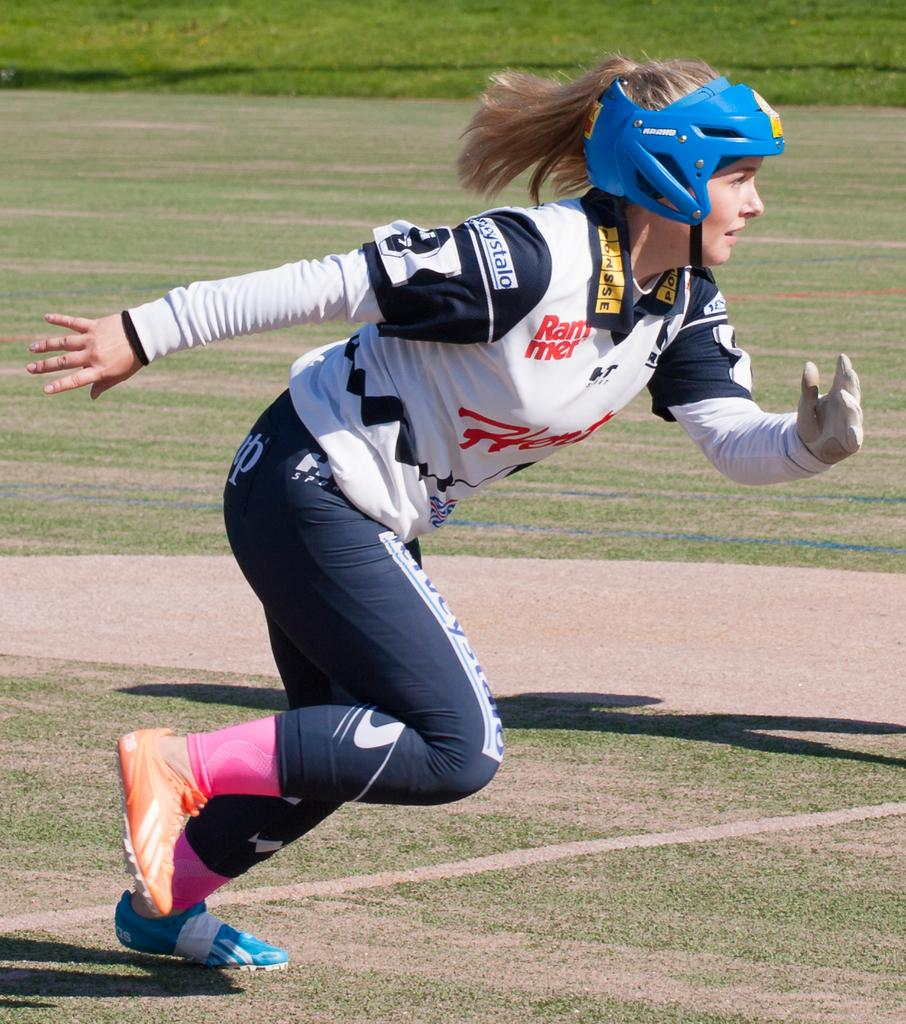Who is present in the image? There is a lady in the image. What is the lady wearing on her head? The lady is wearing a helmet. What activity is the lady engaged in? The lady is running. What type of surface is the lady running on? There is grass on the ground in the image. What type of toys can be seen in the lady's hands in the image? There are no toys visible in the lady's hands in the image. Can you tell me what the lady is talking about while running? The image does not provide any information about what the lady might be talking about while running. 